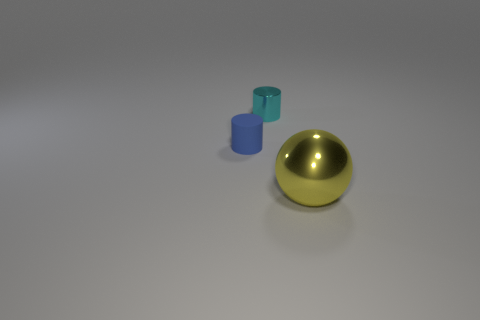What color is the cylinder that is to the left of the tiny object on the right side of the small rubber cylinder?
Provide a succinct answer. Blue. There is a thing that is in front of the small blue matte cylinder; does it have the same shape as the tiny object that is to the left of the cyan object?
Keep it short and to the point. No. There is another object that is the same size as the matte object; what is its shape?
Offer a very short reply. Cylinder. What color is the big object that is made of the same material as the small cyan cylinder?
Offer a terse response. Yellow. Is the shape of the large yellow object the same as the shiny thing that is behind the large yellow thing?
Offer a terse response. No. What material is the blue cylinder that is the same size as the cyan shiny cylinder?
Make the answer very short. Rubber. Is there another matte cylinder that has the same color as the rubber cylinder?
Your response must be concise. No. What is the shape of the thing that is on the left side of the large ball and right of the tiny blue rubber cylinder?
Your answer should be very brief. Cylinder. What number of small yellow cylinders are the same material as the cyan cylinder?
Ensure brevity in your answer.  0. Is the number of shiny cylinders that are left of the blue cylinder less than the number of big metallic balls that are behind the big yellow metal ball?
Keep it short and to the point. No. 